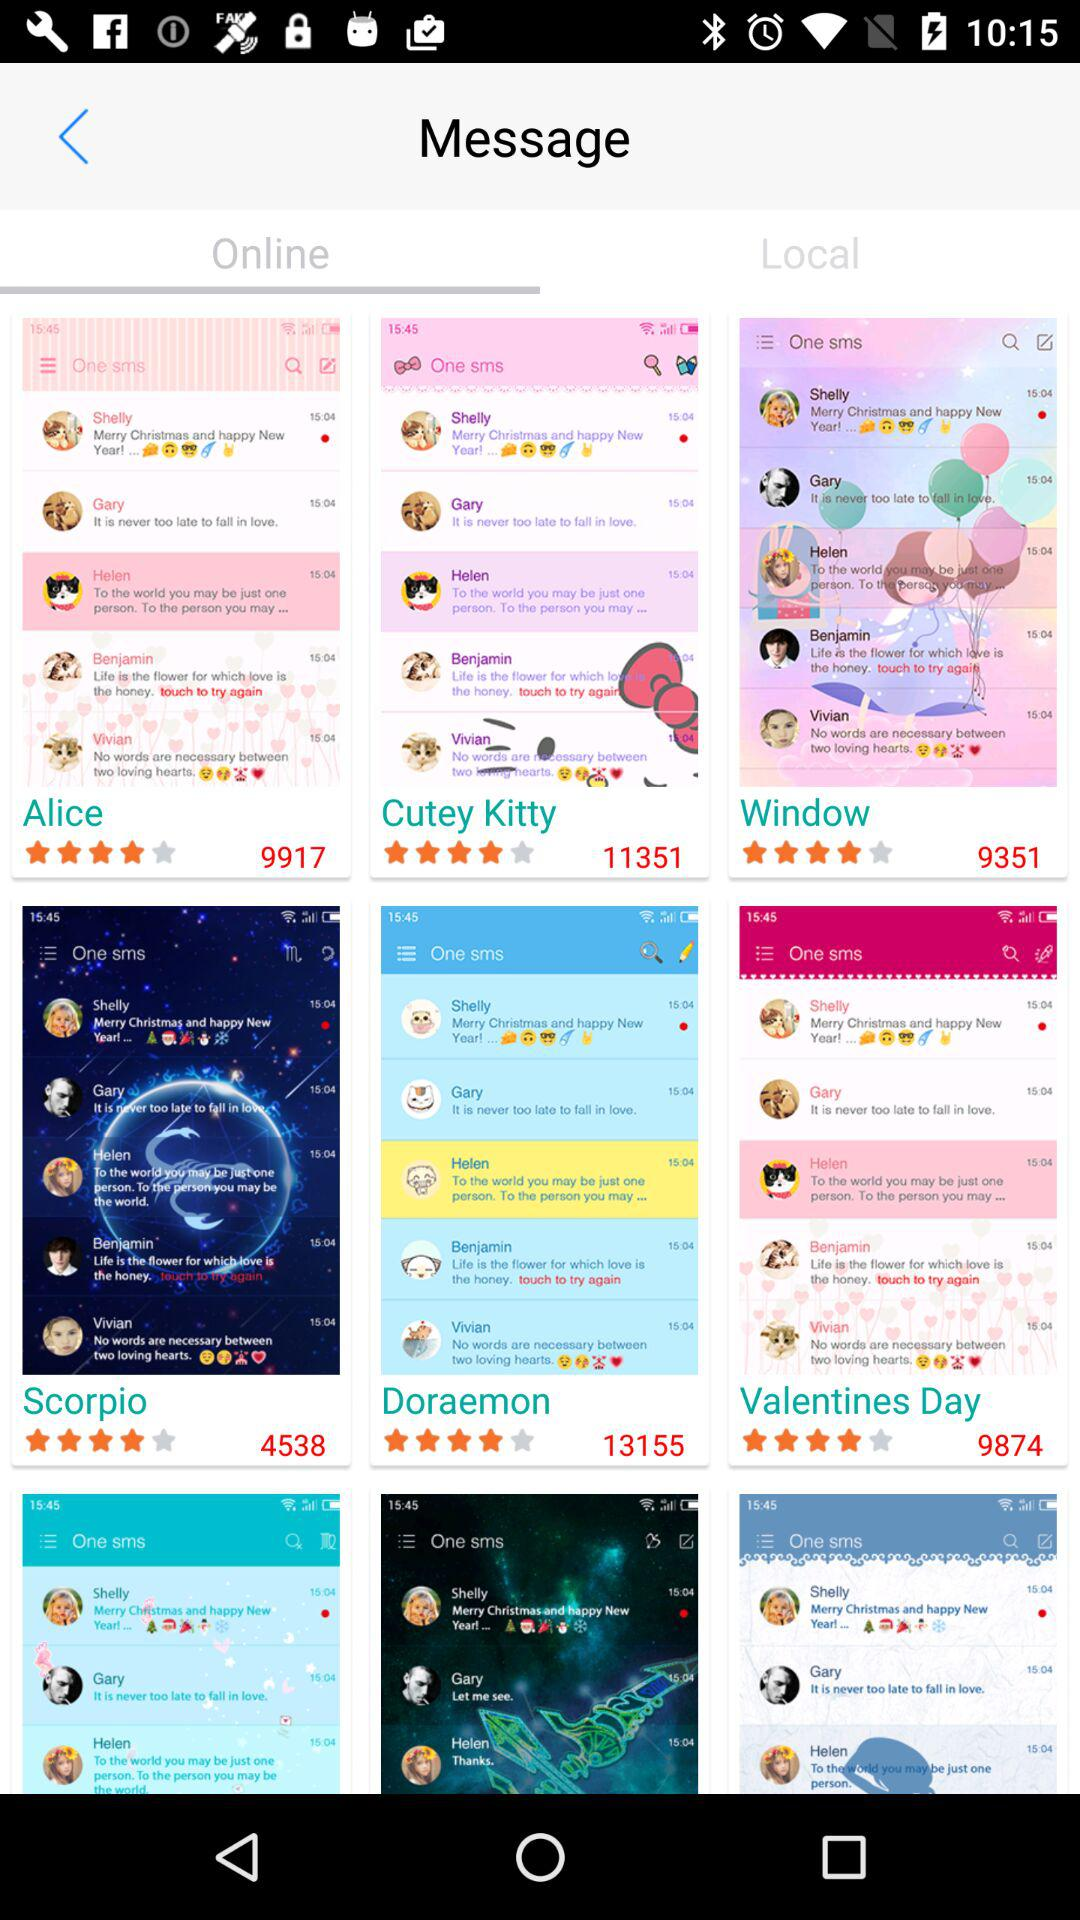How many users have rated "Scorpio"? There are 4538 users who have rated "Scorpio". 